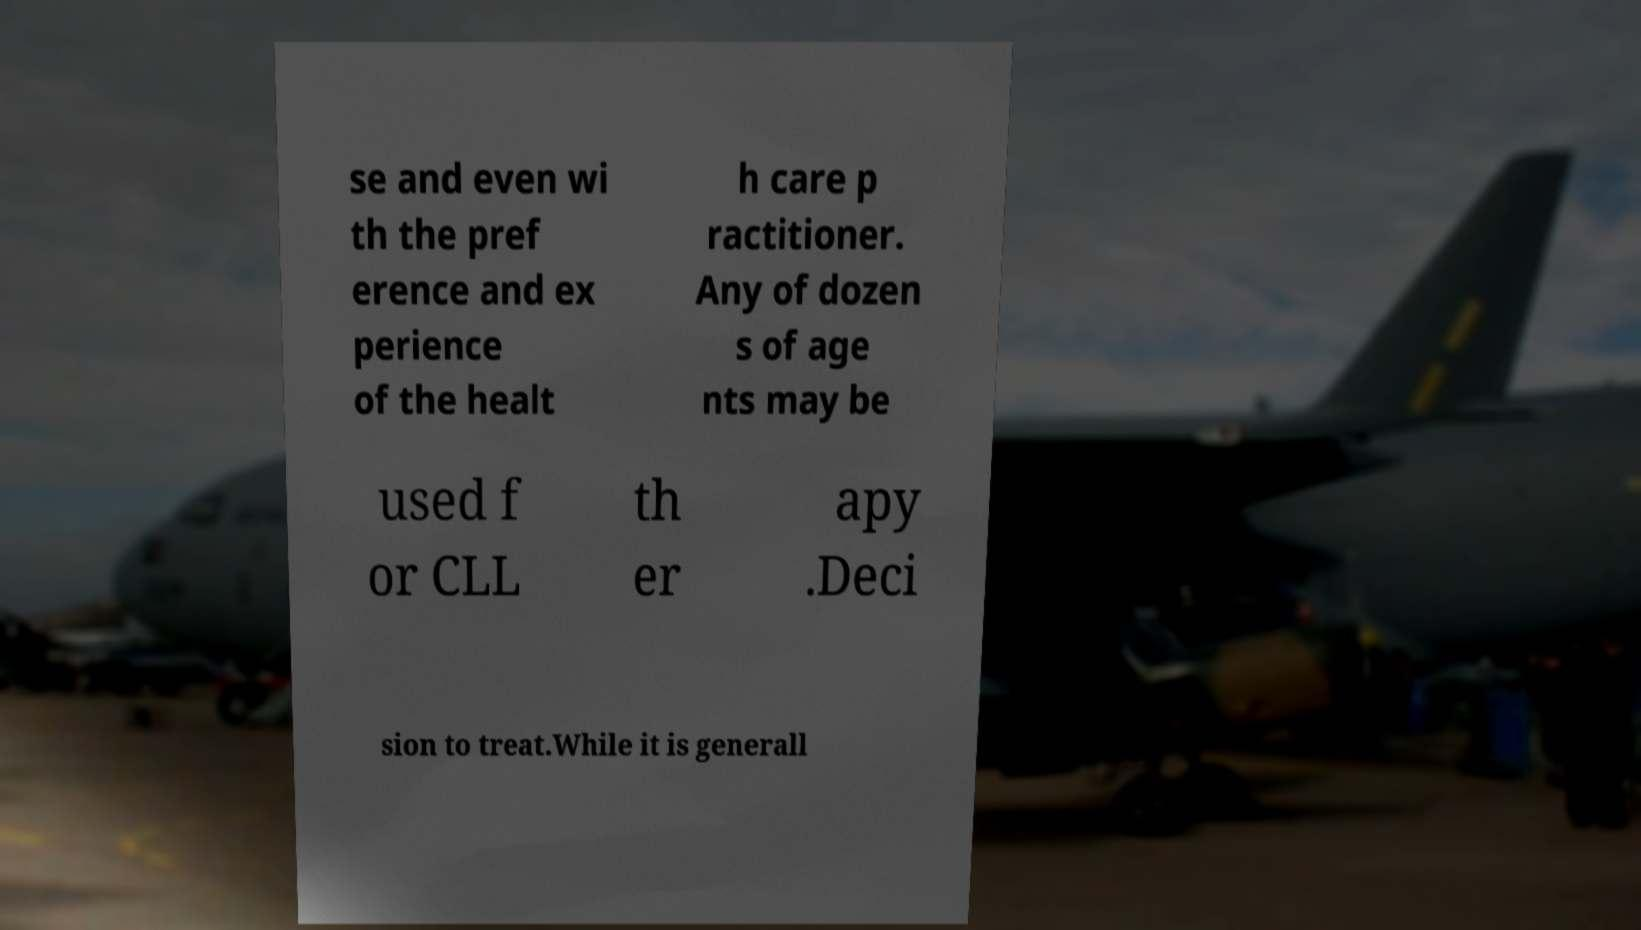For documentation purposes, I need the text within this image transcribed. Could you provide that? se and even wi th the pref erence and ex perience of the healt h care p ractitioner. Any of dozen s of age nts may be used f or CLL th er apy .Deci sion to treat.While it is generall 